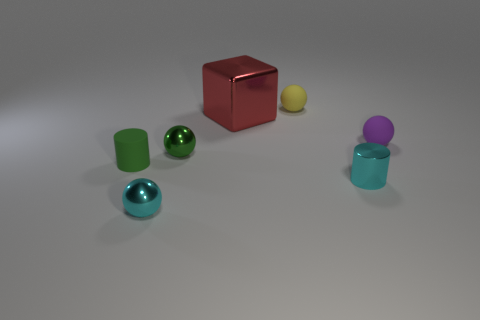There is a large object that is the same material as the cyan ball; what is its color?
Offer a very short reply. Red. Is there anything else that is the same size as the cyan cylinder?
Make the answer very short. Yes. How many things are matte objects in front of the big metal block or small matte balls in front of the big red metal block?
Make the answer very short. 2. There is a cylinder on the left side of the yellow rubber object; is it the same size as the cyan thing that is to the left of the big red thing?
Your answer should be very brief. Yes. What color is the other tiny matte object that is the same shape as the tiny yellow thing?
Your answer should be compact. Purple. Is there anything else that is the same shape as the big red thing?
Your response must be concise. No. Is the number of small objects behind the green metallic sphere greater than the number of small rubber spheres that are behind the big red metal thing?
Offer a terse response. Yes. What size is the cylinder behind the tiny cyan metal object that is on the right side of the green object that is to the right of the small green matte cylinder?
Provide a succinct answer. Small. Is the material of the small cyan cylinder the same as the small cylinder that is left of the green metallic ball?
Provide a short and direct response. No. Is the shape of the purple object the same as the tiny yellow object?
Your answer should be compact. Yes. 